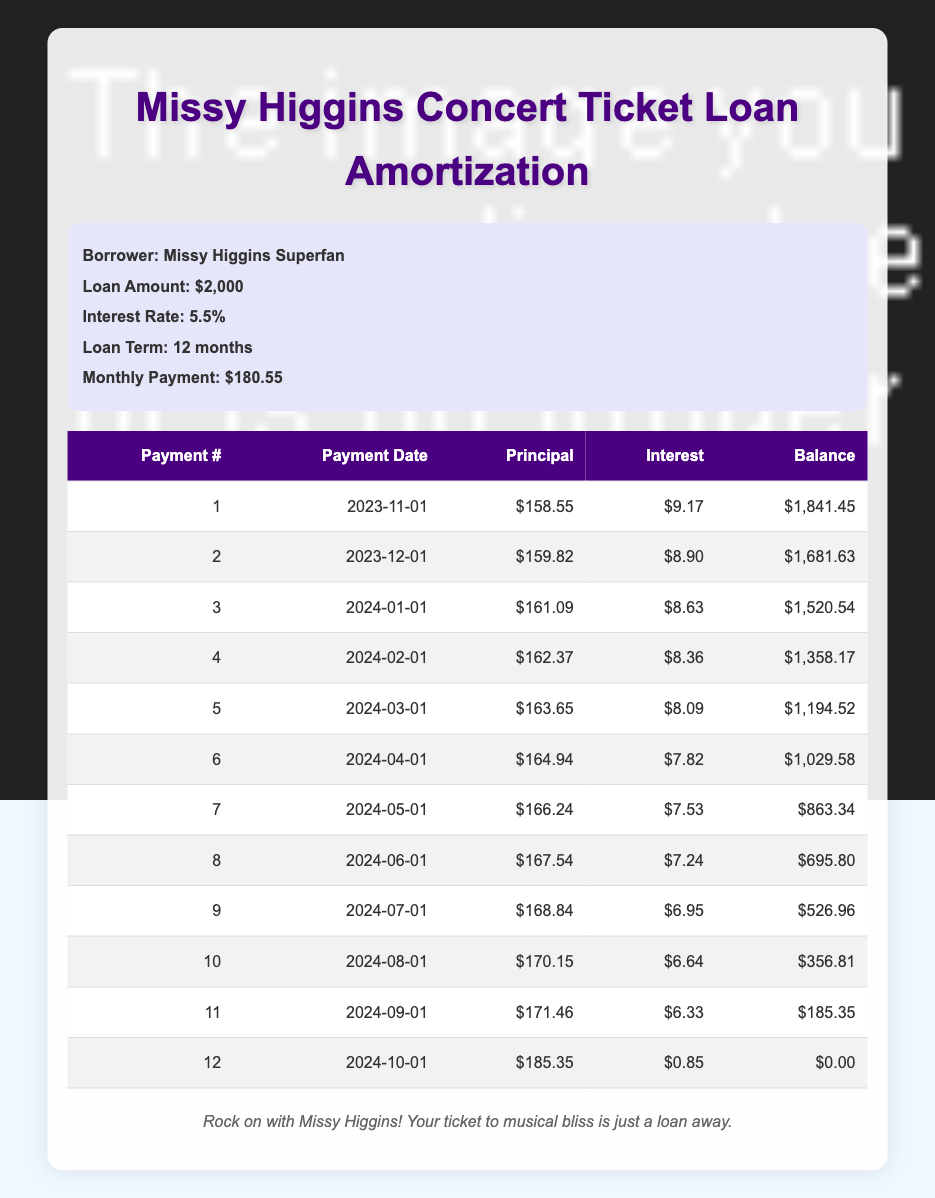What is the total amount of principal paid over the loan term? To find the total principal paid, we can sum the principal payment amounts from each payment: 158.55 + 159.82 + 161.09 + 162.37 + 163.65 + 164.94 + 166.24 + 167.54 + 168.84 + 170.15 + 171.46 + 185.35 = 1,999.65. The total amount rounded is approximately $2,000.
Answer: 2000 What was the interest payment for the first month? The interest payment for the first month is displayed in the table under the "Interest" column for the first payment. It is 9.17.
Answer: 9.17 On which payment date did the remaining balance first drop below $700? We look for the first entry in the "Remaining Balance" column that is less than $700. The balance drops below this amount after the 8th payment on June 1, 2024, which has a remaining balance of 695.80.
Answer: 2024-06-01 How much interest did Missy Higgins Superfan pay in total over the loan? We sum all the interest payments from the table: 9.17 + 8.90 + 8.63 + 8.36 + 8.09 + 7.82 + 7.53 + 7.24 + 6.95 + 6.64 + 6.33 + 0.85 = 78.08. This gives us the total interest paid.
Answer: 78.08 Was the principal payment higher in the second month compared to the first month? We compare the principal payments from the first and second months. The first month's principal payment is 158.55, and the second month’s is 159.82. Since 159.82 is greater than 158.55, this statement is true.
Answer: Yes What is the average monthly payment made into the loan over the 12 months? The monthly payment is uniformly $180.55 throughout the 12 months. Therefore, the average monthly payment is simply $180.55.
Answer: 180.55 How much did the remaining balance decrease from the first month to the last month? The remaining balance in the first month is 1841.45, and in the last month, it is 0.00. To find the decrease, we subtract the last month's remaining balance from the first month's: 1841.45 - 0.00 = 1841.45.
Answer: 1841.45 By how much did the principal payment change from the first to the last payment? We look at the principal payment amounts for the first and last payments: First month is 158.55, and the last month is 185.35. The change is calculated as 185.35 - 158.55 = 26.80.
Answer: 26.80 